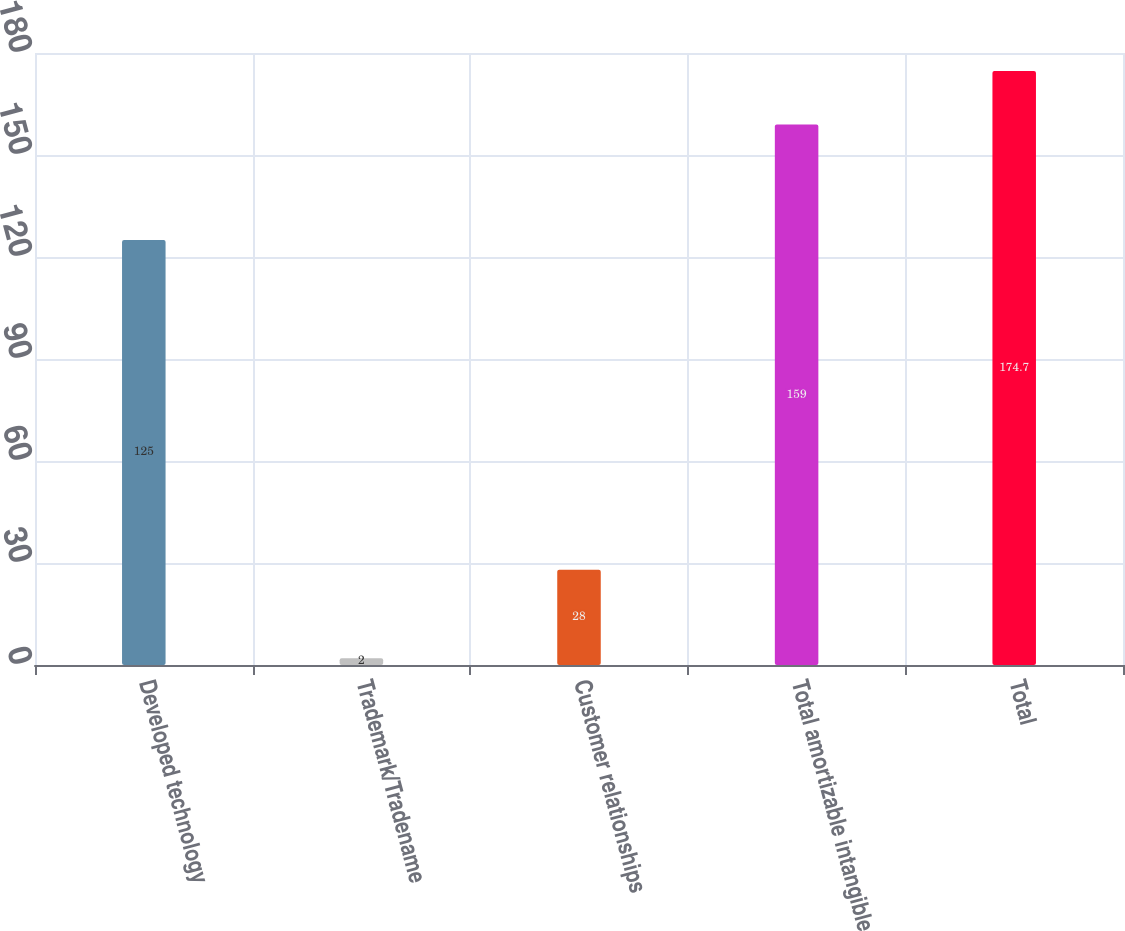Convert chart to OTSL. <chart><loc_0><loc_0><loc_500><loc_500><bar_chart><fcel>Developed technology<fcel>Trademark/Tradename<fcel>Customer relationships<fcel>Total amortizable intangible<fcel>Total<nl><fcel>125<fcel>2<fcel>28<fcel>159<fcel>174.7<nl></chart> 